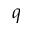Convert formula to latex. <formula><loc_0><loc_0><loc_500><loc_500>q</formula> 